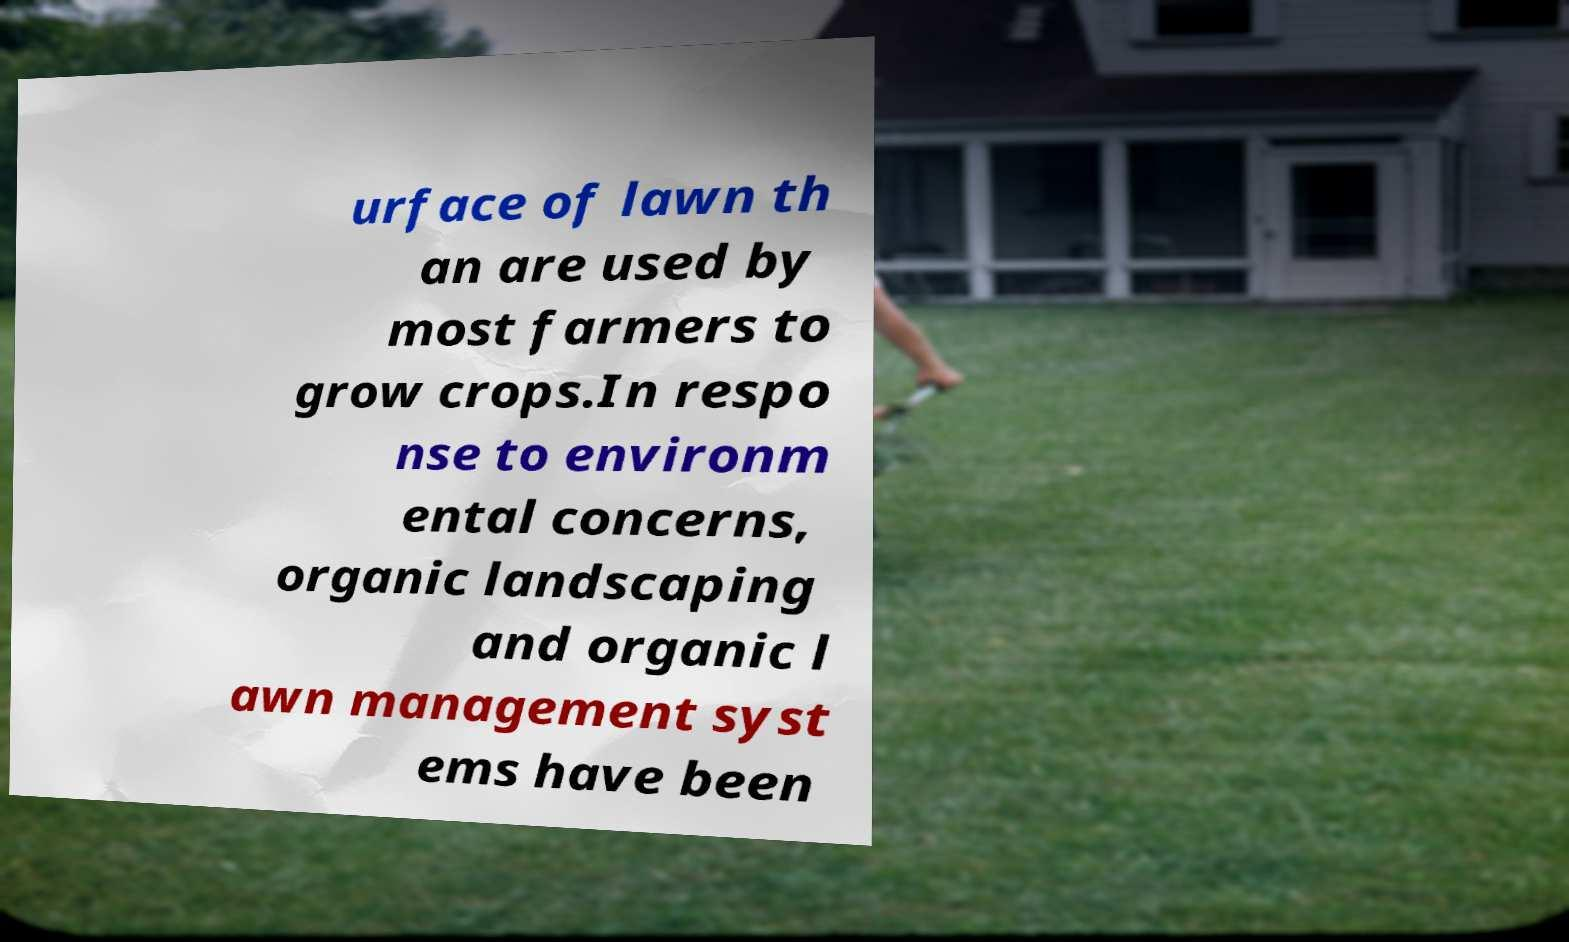Please read and relay the text visible in this image. What does it say? urface of lawn th an are used by most farmers to grow crops.In respo nse to environm ental concerns, organic landscaping and organic l awn management syst ems have been 